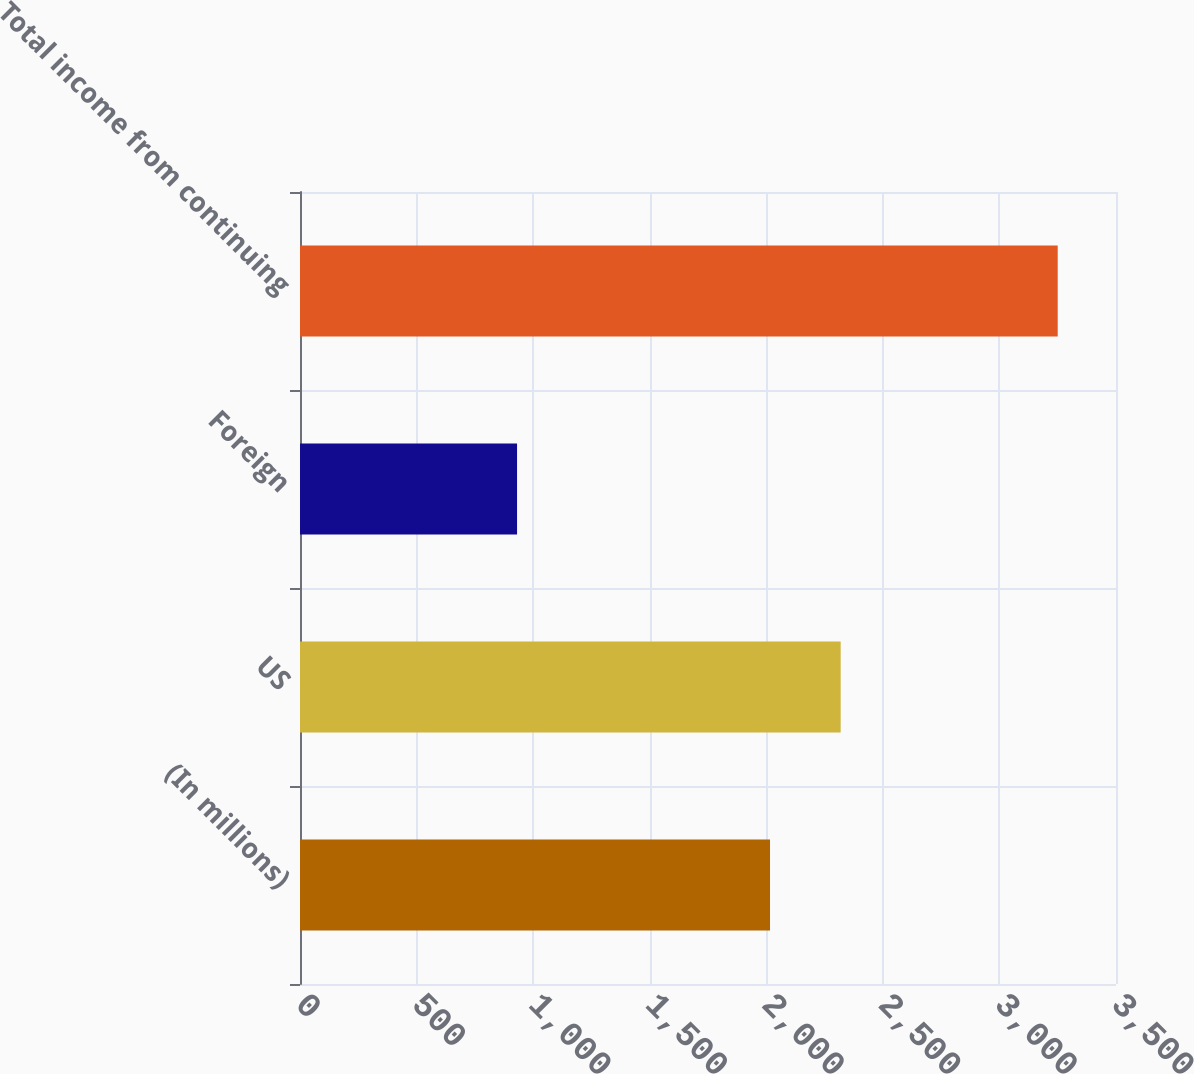Convert chart to OTSL. <chart><loc_0><loc_0><loc_500><loc_500><bar_chart><fcel>(In millions)<fcel>US<fcel>Foreign<fcel>Total income from continuing<nl><fcel>2016<fcel>2319<fcel>931<fcel>3250<nl></chart> 